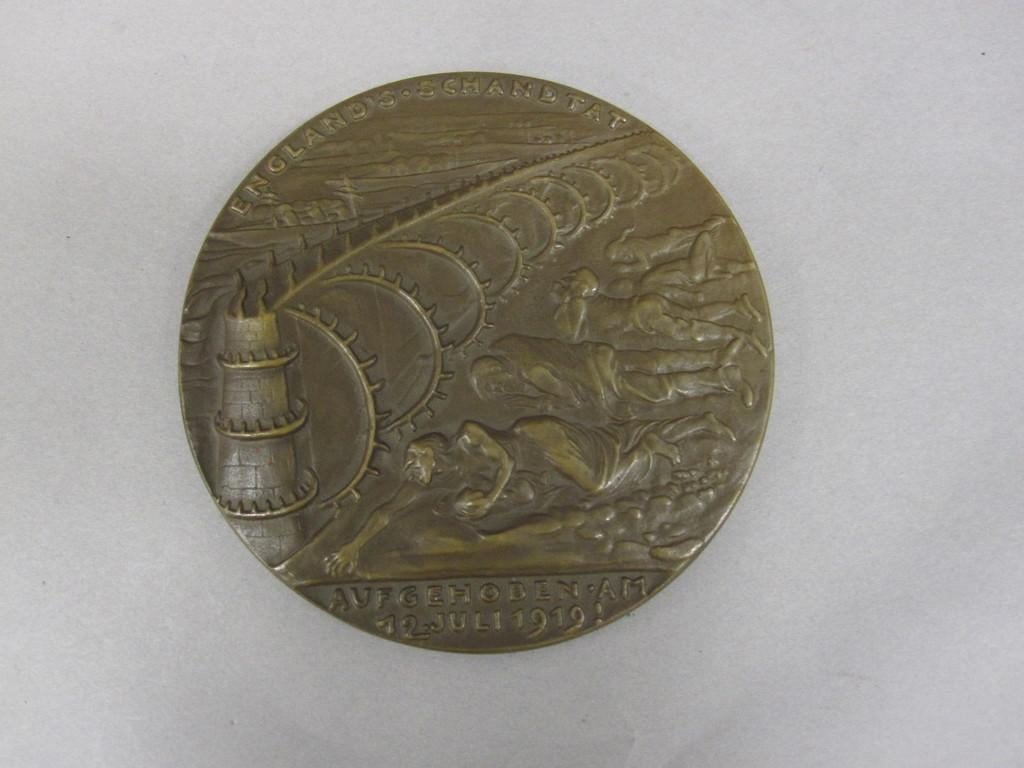<image>
Share a concise interpretation of the image provided. An old coin with the word Aufgehoben on it. 